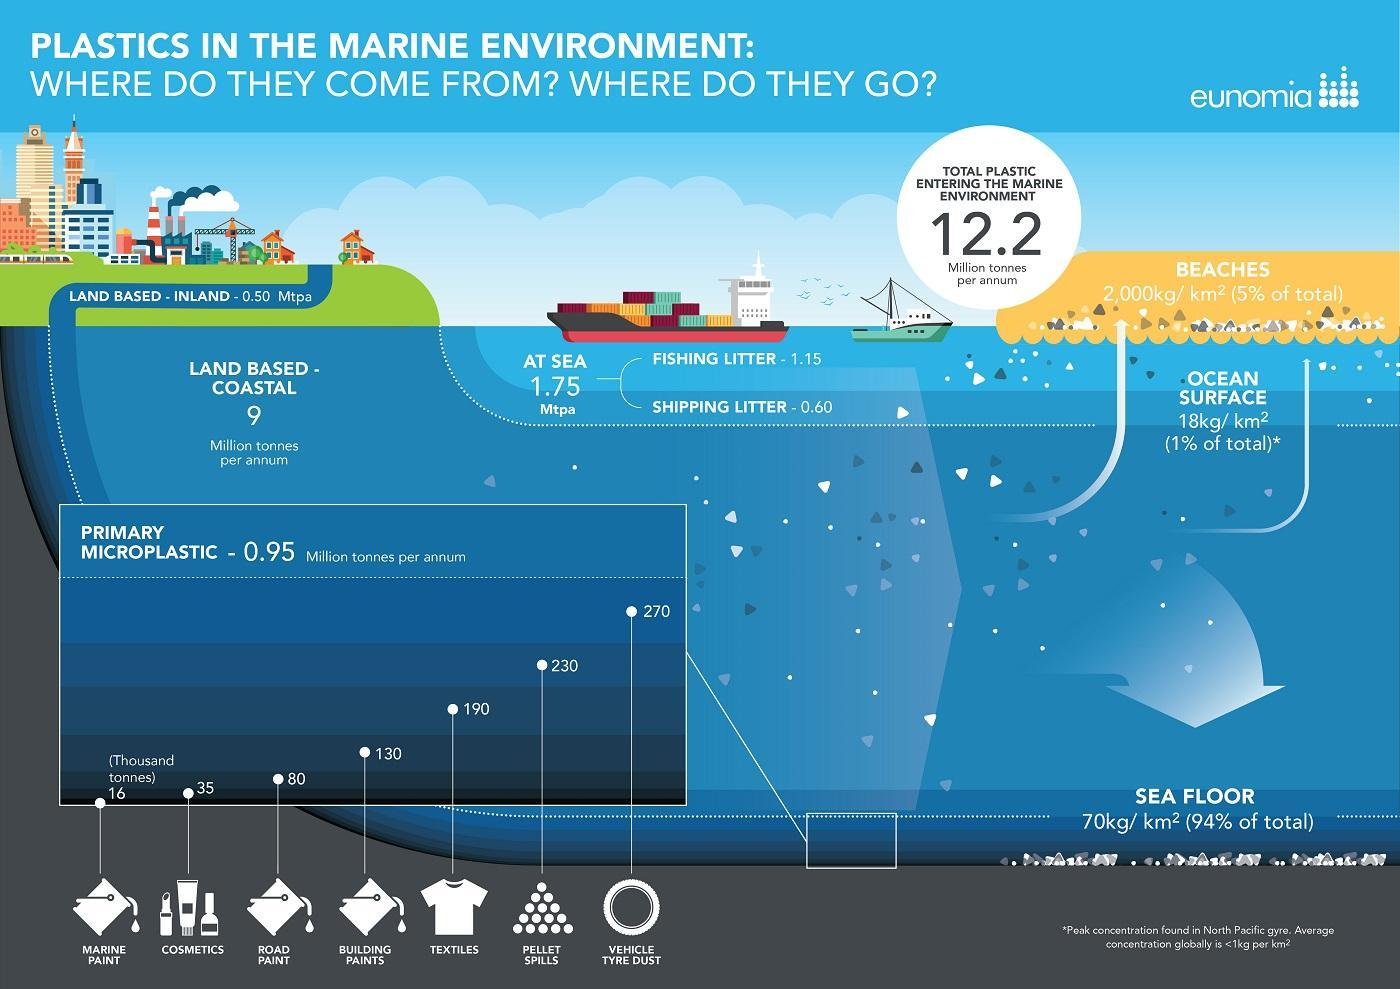What amount of textile microplastic is found in the sea?
Answer the question with a short phrase. 190 Thousand tonnes Which primary microplastic is found in the largest amount in oceans? VEHICLE TYRE DUST Which microplastic is found in 130 thousand tonnes in the oceans? BUILDING PAINTS 